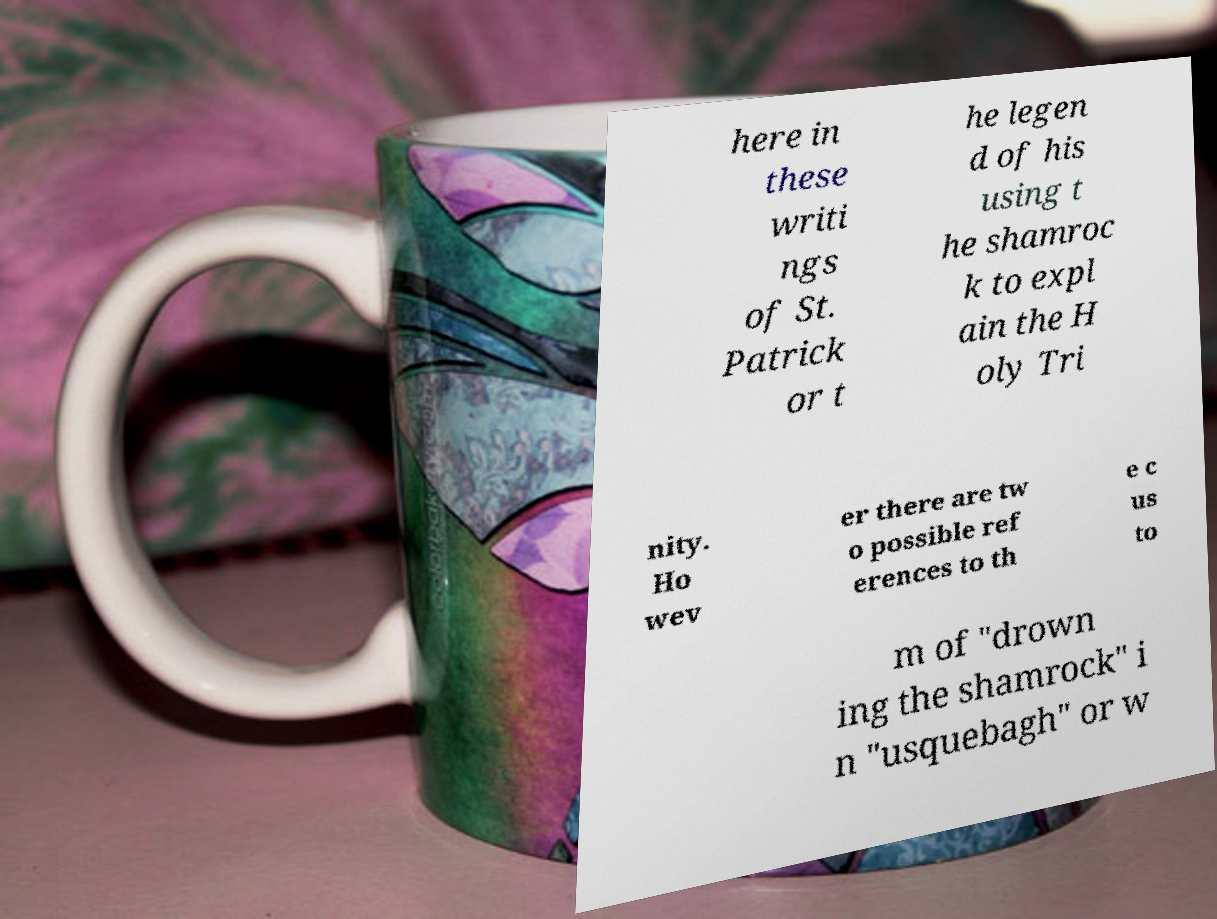Could you extract and type out the text from this image? here in these writi ngs of St. Patrick or t he legen d of his using t he shamroc k to expl ain the H oly Tri nity. Ho wev er there are tw o possible ref erences to th e c us to m of "drown ing the shamrock" i n "usquebagh" or w 